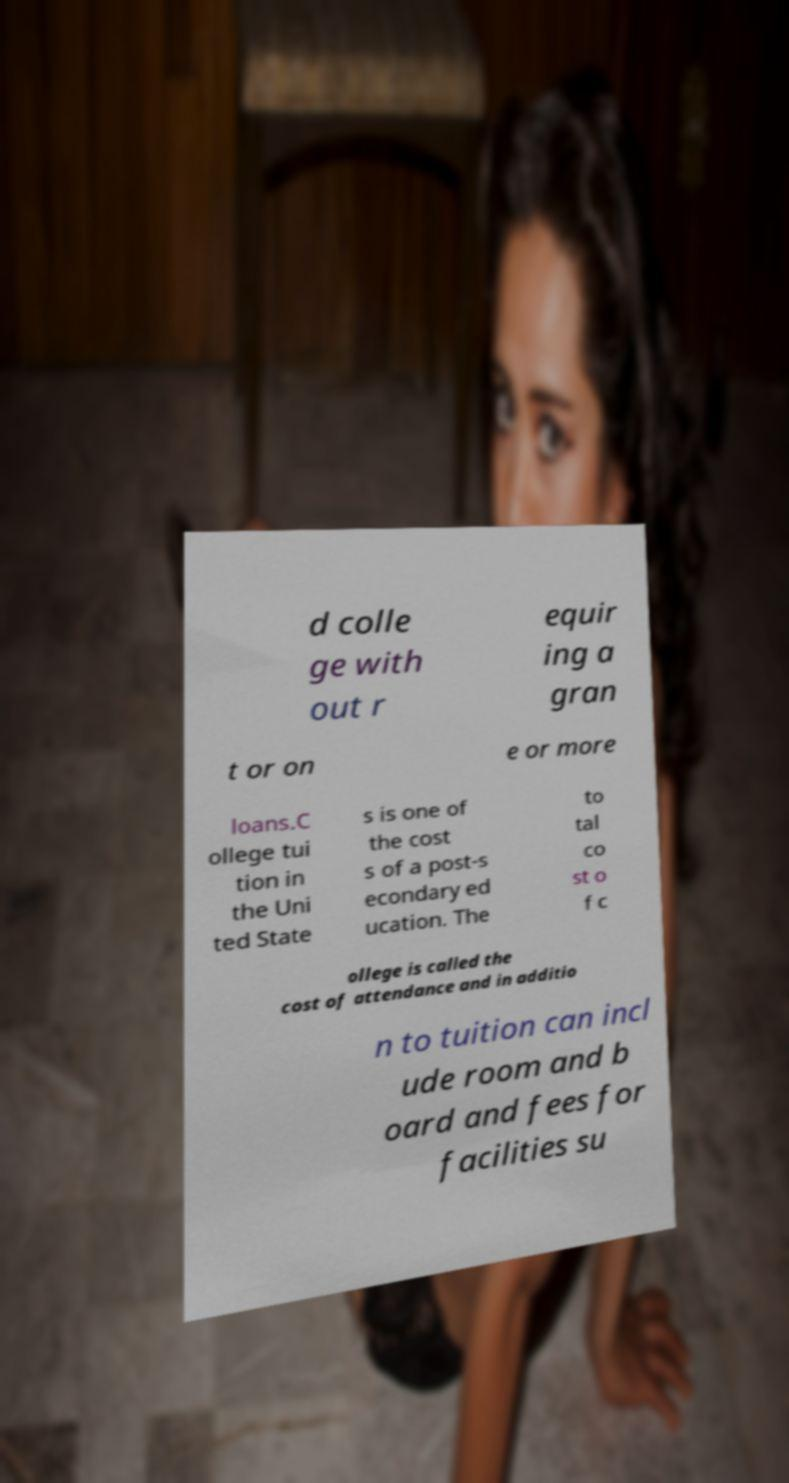Please read and relay the text visible in this image. What does it say? d colle ge with out r equir ing a gran t or on e or more loans.C ollege tui tion in the Uni ted State s is one of the cost s of a post-s econdary ed ucation. The to tal co st o f c ollege is called the cost of attendance and in additio n to tuition can incl ude room and b oard and fees for facilities su 